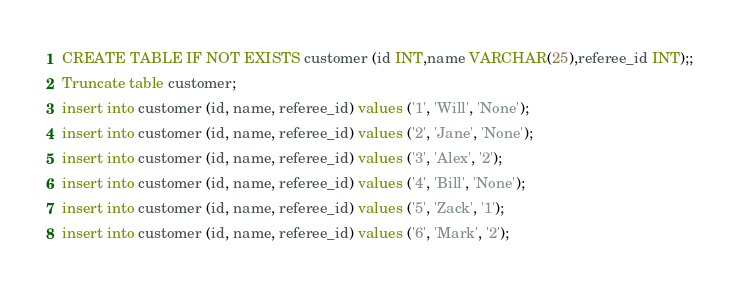Convert code to text. <code><loc_0><loc_0><loc_500><loc_500><_SQL_>CREATE TABLE IF NOT EXISTS customer (id INT,name VARCHAR(25),referee_id INT);;
Truncate table customer;
insert into customer (id, name, referee_id) values ('1', 'Will', 'None');
insert into customer (id, name, referee_id) values ('2', 'Jane', 'None');
insert into customer (id, name, referee_id) values ('3', 'Alex', '2');
insert into customer (id, name, referee_id) values ('4', 'Bill', 'None');
insert into customer (id, name, referee_id) values ('5', 'Zack', '1');
insert into customer (id, name, referee_id) values ('6', 'Mark', '2');
</code> 